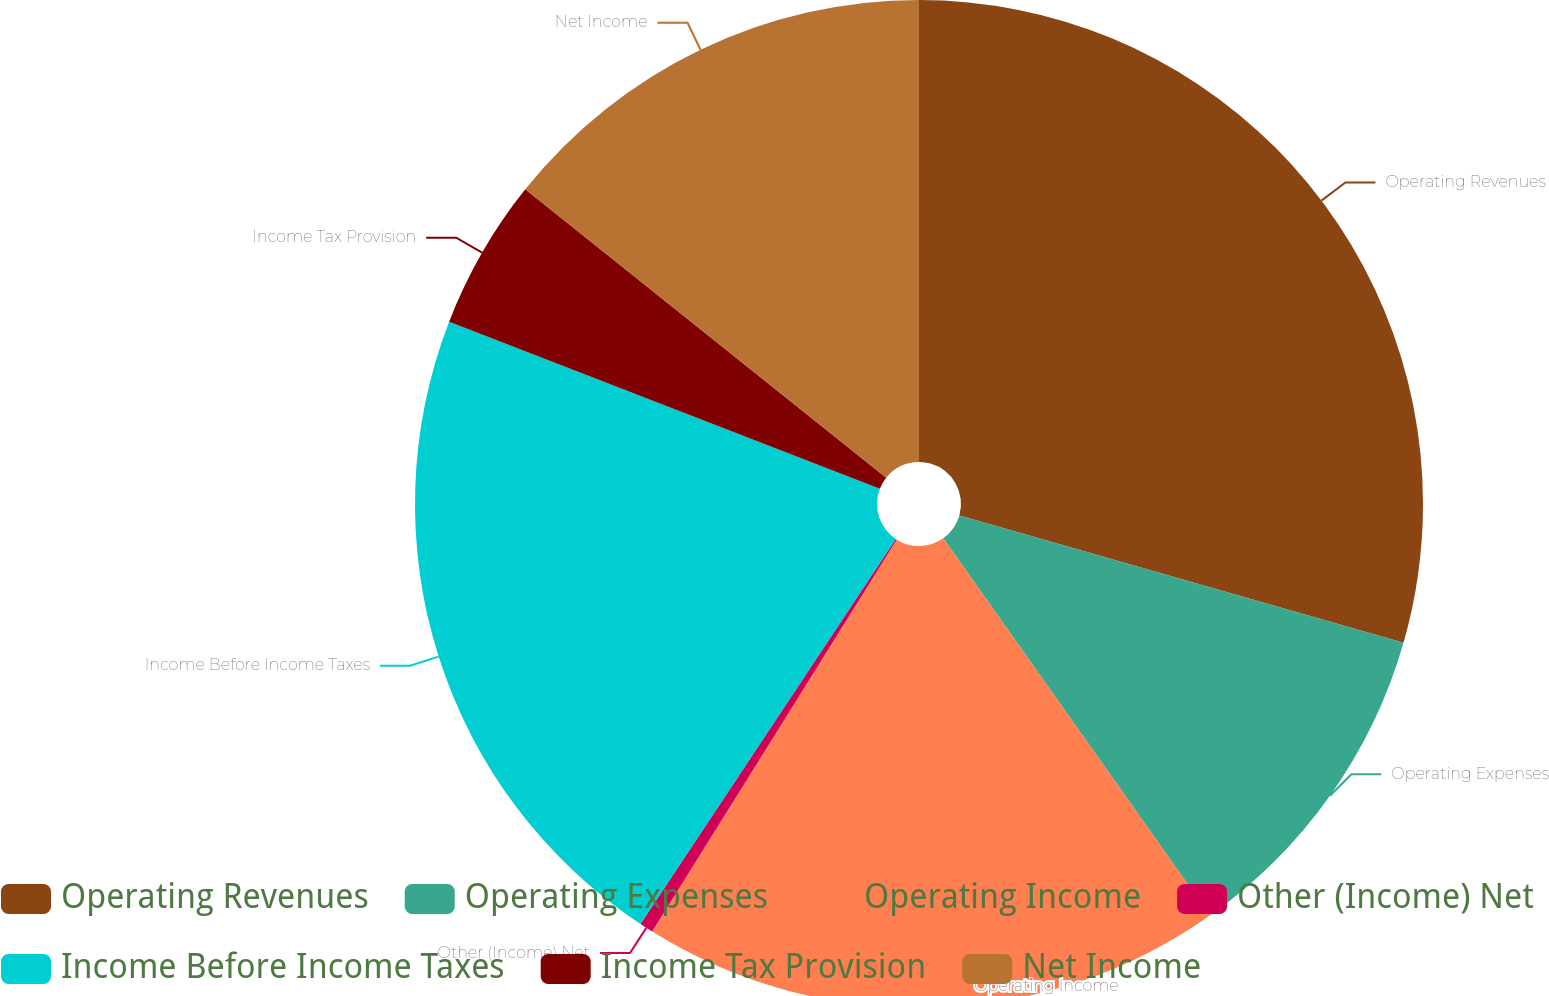<chart> <loc_0><loc_0><loc_500><loc_500><pie_chart><fcel>Operating Revenues<fcel>Operating Expenses<fcel>Operating Income<fcel>Other (Income) Net<fcel>Income Before Income Taxes<fcel>Income Tax Provision<fcel>Net Income<nl><fcel>29.44%<fcel>10.77%<fcel>18.67%<fcel>0.44%<fcel>21.57%<fcel>4.84%<fcel>14.27%<nl></chart> 